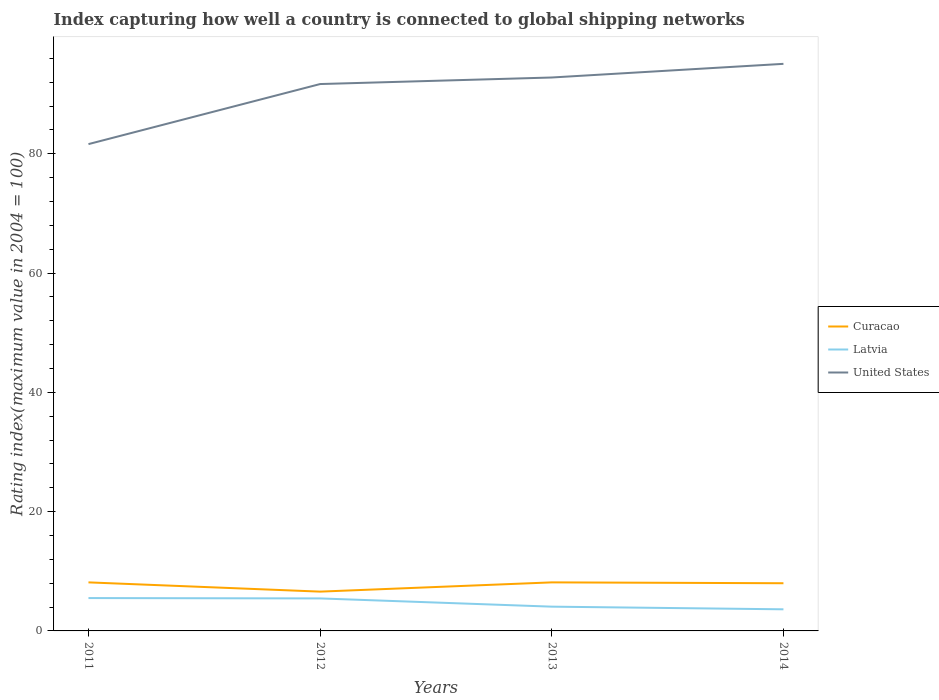How many different coloured lines are there?
Your response must be concise. 3. Does the line corresponding to United States intersect with the line corresponding to Curacao?
Your answer should be very brief. No. Is the number of lines equal to the number of legend labels?
Your response must be concise. Yes. Across all years, what is the maximum rating index in Curacao?
Offer a very short reply. 6.59. In which year was the rating index in United States maximum?
Offer a terse response. 2011. What is the difference between the highest and the second highest rating index in Curacao?
Offer a terse response. 1.55. What is the difference between the highest and the lowest rating index in Latvia?
Keep it short and to the point. 2. Is the rating index in United States strictly greater than the rating index in Latvia over the years?
Make the answer very short. No. How many lines are there?
Give a very brief answer. 3. Does the graph contain grids?
Offer a very short reply. No. How many legend labels are there?
Make the answer very short. 3. How are the legend labels stacked?
Ensure brevity in your answer.  Vertical. What is the title of the graph?
Offer a terse response. Index capturing how well a country is connected to global shipping networks. What is the label or title of the Y-axis?
Give a very brief answer. Rating index(maximum value in 2004 = 100). What is the Rating index(maximum value in 2004 = 100) of Curacao in 2011?
Give a very brief answer. 8.14. What is the Rating index(maximum value in 2004 = 100) of Latvia in 2011?
Your response must be concise. 5.51. What is the Rating index(maximum value in 2004 = 100) in United States in 2011?
Make the answer very short. 81.63. What is the Rating index(maximum value in 2004 = 100) in Curacao in 2012?
Make the answer very short. 6.59. What is the Rating index(maximum value in 2004 = 100) of Latvia in 2012?
Your answer should be very brief. 5.45. What is the Rating index(maximum value in 2004 = 100) of United States in 2012?
Your response must be concise. 91.7. What is the Rating index(maximum value in 2004 = 100) in Curacao in 2013?
Your response must be concise. 8.14. What is the Rating index(maximum value in 2004 = 100) in Latvia in 2013?
Ensure brevity in your answer.  4.07. What is the Rating index(maximum value in 2004 = 100) of United States in 2013?
Provide a succinct answer. 92.8. What is the Rating index(maximum value in 2004 = 100) in Curacao in 2014?
Provide a succinct answer. 8. What is the Rating index(maximum value in 2004 = 100) of Latvia in 2014?
Your answer should be very brief. 3.62. What is the Rating index(maximum value in 2004 = 100) in United States in 2014?
Your response must be concise. 95.09. Across all years, what is the maximum Rating index(maximum value in 2004 = 100) in Curacao?
Provide a succinct answer. 8.14. Across all years, what is the maximum Rating index(maximum value in 2004 = 100) of Latvia?
Your answer should be very brief. 5.51. Across all years, what is the maximum Rating index(maximum value in 2004 = 100) in United States?
Ensure brevity in your answer.  95.09. Across all years, what is the minimum Rating index(maximum value in 2004 = 100) of Curacao?
Give a very brief answer. 6.59. Across all years, what is the minimum Rating index(maximum value in 2004 = 100) of Latvia?
Your answer should be compact. 3.62. Across all years, what is the minimum Rating index(maximum value in 2004 = 100) of United States?
Your response must be concise. 81.63. What is the total Rating index(maximum value in 2004 = 100) of Curacao in the graph?
Offer a very short reply. 30.87. What is the total Rating index(maximum value in 2004 = 100) of Latvia in the graph?
Keep it short and to the point. 18.65. What is the total Rating index(maximum value in 2004 = 100) in United States in the graph?
Provide a short and direct response. 361.22. What is the difference between the Rating index(maximum value in 2004 = 100) in Curacao in 2011 and that in 2012?
Give a very brief answer. 1.55. What is the difference between the Rating index(maximum value in 2004 = 100) of United States in 2011 and that in 2012?
Provide a short and direct response. -10.07. What is the difference between the Rating index(maximum value in 2004 = 100) in Latvia in 2011 and that in 2013?
Keep it short and to the point. 1.44. What is the difference between the Rating index(maximum value in 2004 = 100) of United States in 2011 and that in 2013?
Keep it short and to the point. -11.17. What is the difference between the Rating index(maximum value in 2004 = 100) of Curacao in 2011 and that in 2014?
Offer a terse response. 0.14. What is the difference between the Rating index(maximum value in 2004 = 100) in Latvia in 2011 and that in 2014?
Provide a succinct answer. 1.89. What is the difference between the Rating index(maximum value in 2004 = 100) of United States in 2011 and that in 2014?
Your answer should be compact. -13.46. What is the difference between the Rating index(maximum value in 2004 = 100) of Curacao in 2012 and that in 2013?
Provide a succinct answer. -1.55. What is the difference between the Rating index(maximum value in 2004 = 100) of Latvia in 2012 and that in 2013?
Your answer should be compact. 1.38. What is the difference between the Rating index(maximum value in 2004 = 100) in United States in 2012 and that in 2013?
Offer a terse response. -1.1. What is the difference between the Rating index(maximum value in 2004 = 100) of Curacao in 2012 and that in 2014?
Keep it short and to the point. -1.41. What is the difference between the Rating index(maximum value in 2004 = 100) of Latvia in 2012 and that in 2014?
Offer a very short reply. 1.83. What is the difference between the Rating index(maximum value in 2004 = 100) of United States in 2012 and that in 2014?
Offer a very short reply. -3.39. What is the difference between the Rating index(maximum value in 2004 = 100) in Curacao in 2013 and that in 2014?
Provide a succinct answer. 0.14. What is the difference between the Rating index(maximum value in 2004 = 100) of Latvia in 2013 and that in 2014?
Give a very brief answer. 0.45. What is the difference between the Rating index(maximum value in 2004 = 100) in United States in 2013 and that in 2014?
Give a very brief answer. -2.29. What is the difference between the Rating index(maximum value in 2004 = 100) in Curacao in 2011 and the Rating index(maximum value in 2004 = 100) in Latvia in 2012?
Keep it short and to the point. 2.69. What is the difference between the Rating index(maximum value in 2004 = 100) of Curacao in 2011 and the Rating index(maximum value in 2004 = 100) of United States in 2012?
Ensure brevity in your answer.  -83.56. What is the difference between the Rating index(maximum value in 2004 = 100) in Latvia in 2011 and the Rating index(maximum value in 2004 = 100) in United States in 2012?
Your response must be concise. -86.19. What is the difference between the Rating index(maximum value in 2004 = 100) of Curacao in 2011 and the Rating index(maximum value in 2004 = 100) of Latvia in 2013?
Offer a very short reply. 4.07. What is the difference between the Rating index(maximum value in 2004 = 100) in Curacao in 2011 and the Rating index(maximum value in 2004 = 100) in United States in 2013?
Provide a succinct answer. -84.66. What is the difference between the Rating index(maximum value in 2004 = 100) of Latvia in 2011 and the Rating index(maximum value in 2004 = 100) of United States in 2013?
Give a very brief answer. -87.29. What is the difference between the Rating index(maximum value in 2004 = 100) of Curacao in 2011 and the Rating index(maximum value in 2004 = 100) of Latvia in 2014?
Offer a terse response. 4.52. What is the difference between the Rating index(maximum value in 2004 = 100) in Curacao in 2011 and the Rating index(maximum value in 2004 = 100) in United States in 2014?
Your response must be concise. -86.95. What is the difference between the Rating index(maximum value in 2004 = 100) of Latvia in 2011 and the Rating index(maximum value in 2004 = 100) of United States in 2014?
Make the answer very short. -89.58. What is the difference between the Rating index(maximum value in 2004 = 100) in Curacao in 2012 and the Rating index(maximum value in 2004 = 100) in Latvia in 2013?
Provide a short and direct response. 2.52. What is the difference between the Rating index(maximum value in 2004 = 100) in Curacao in 2012 and the Rating index(maximum value in 2004 = 100) in United States in 2013?
Ensure brevity in your answer.  -86.21. What is the difference between the Rating index(maximum value in 2004 = 100) of Latvia in 2012 and the Rating index(maximum value in 2004 = 100) of United States in 2013?
Offer a terse response. -87.35. What is the difference between the Rating index(maximum value in 2004 = 100) of Curacao in 2012 and the Rating index(maximum value in 2004 = 100) of Latvia in 2014?
Your answer should be compact. 2.97. What is the difference between the Rating index(maximum value in 2004 = 100) of Curacao in 2012 and the Rating index(maximum value in 2004 = 100) of United States in 2014?
Provide a short and direct response. -88.5. What is the difference between the Rating index(maximum value in 2004 = 100) in Latvia in 2012 and the Rating index(maximum value in 2004 = 100) in United States in 2014?
Make the answer very short. -89.64. What is the difference between the Rating index(maximum value in 2004 = 100) of Curacao in 2013 and the Rating index(maximum value in 2004 = 100) of Latvia in 2014?
Offer a terse response. 4.52. What is the difference between the Rating index(maximum value in 2004 = 100) of Curacao in 2013 and the Rating index(maximum value in 2004 = 100) of United States in 2014?
Keep it short and to the point. -86.95. What is the difference between the Rating index(maximum value in 2004 = 100) of Latvia in 2013 and the Rating index(maximum value in 2004 = 100) of United States in 2014?
Make the answer very short. -91.02. What is the average Rating index(maximum value in 2004 = 100) of Curacao per year?
Give a very brief answer. 7.72. What is the average Rating index(maximum value in 2004 = 100) in Latvia per year?
Keep it short and to the point. 4.66. What is the average Rating index(maximum value in 2004 = 100) in United States per year?
Offer a terse response. 90.3. In the year 2011, what is the difference between the Rating index(maximum value in 2004 = 100) in Curacao and Rating index(maximum value in 2004 = 100) in Latvia?
Your response must be concise. 2.63. In the year 2011, what is the difference between the Rating index(maximum value in 2004 = 100) of Curacao and Rating index(maximum value in 2004 = 100) of United States?
Keep it short and to the point. -73.49. In the year 2011, what is the difference between the Rating index(maximum value in 2004 = 100) in Latvia and Rating index(maximum value in 2004 = 100) in United States?
Make the answer very short. -76.12. In the year 2012, what is the difference between the Rating index(maximum value in 2004 = 100) of Curacao and Rating index(maximum value in 2004 = 100) of Latvia?
Give a very brief answer. 1.14. In the year 2012, what is the difference between the Rating index(maximum value in 2004 = 100) of Curacao and Rating index(maximum value in 2004 = 100) of United States?
Keep it short and to the point. -85.11. In the year 2012, what is the difference between the Rating index(maximum value in 2004 = 100) of Latvia and Rating index(maximum value in 2004 = 100) of United States?
Offer a very short reply. -86.25. In the year 2013, what is the difference between the Rating index(maximum value in 2004 = 100) of Curacao and Rating index(maximum value in 2004 = 100) of Latvia?
Offer a very short reply. 4.07. In the year 2013, what is the difference between the Rating index(maximum value in 2004 = 100) of Curacao and Rating index(maximum value in 2004 = 100) of United States?
Provide a succinct answer. -84.66. In the year 2013, what is the difference between the Rating index(maximum value in 2004 = 100) of Latvia and Rating index(maximum value in 2004 = 100) of United States?
Offer a terse response. -88.73. In the year 2014, what is the difference between the Rating index(maximum value in 2004 = 100) in Curacao and Rating index(maximum value in 2004 = 100) in Latvia?
Your answer should be very brief. 4.37. In the year 2014, what is the difference between the Rating index(maximum value in 2004 = 100) of Curacao and Rating index(maximum value in 2004 = 100) of United States?
Offer a terse response. -87.09. In the year 2014, what is the difference between the Rating index(maximum value in 2004 = 100) of Latvia and Rating index(maximum value in 2004 = 100) of United States?
Offer a very short reply. -91.46. What is the ratio of the Rating index(maximum value in 2004 = 100) of Curacao in 2011 to that in 2012?
Provide a short and direct response. 1.24. What is the ratio of the Rating index(maximum value in 2004 = 100) of Latvia in 2011 to that in 2012?
Provide a short and direct response. 1.01. What is the ratio of the Rating index(maximum value in 2004 = 100) in United States in 2011 to that in 2012?
Give a very brief answer. 0.89. What is the ratio of the Rating index(maximum value in 2004 = 100) of Curacao in 2011 to that in 2013?
Provide a succinct answer. 1. What is the ratio of the Rating index(maximum value in 2004 = 100) of Latvia in 2011 to that in 2013?
Ensure brevity in your answer.  1.35. What is the ratio of the Rating index(maximum value in 2004 = 100) of United States in 2011 to that in 2013?
Make the answer very short. 0.88. What is the ratio of the Rating index(maximum value in 2004 = 100) in Curacao in 2011 to that in 2014?
Keep it short and to the point. 1.02. What is the ratio of the Rating index(maximum value in 2004 = 100) of Latvia in 2011 to that in 2014?
Provide a short and direct response. 1.52. What is the ratio of the Rating index(maximum value in 2004 = 100) of United States in 2011 to that in 2014?
Provide a succinct answer. 0.86. What is the ratio of the Rating index(maximum value in 2004 = 100) of Curacao in 2012 to that in 2013?
Ensure brevity in your answer.  0.81. What is the ratio of the Rating index(maximum value in 2004 = 100) in Latvia in 2012 to that in 2013?
Provide a succinct answer. 1.34. What is the ratio of the Rating index(maximum value in 2004 = 100) of Curacao in 2012 to that in 2014?
Make the answer very short. 0.82. What is the ratio of the Rating index(maximum value in 2004 = 100) of Latvia in 2012 to that in 2014?
Give a very brief answer. 1.5. What is the ratio of the Rating index(maximum value in 2004 = 100) in United States in 2012 to that in 2014?
Offer a terse response. 0.96. What is the ratio of the Rating index(maximum value in 2004 = 100) of Curacao in 2013 to that in 2014?
Offer a very short reply. 1.02. What is the ratio of the Rating index(maximum value in 2004 = 100) in Latvia in 2013 to that in 2014?
Your response must be concise. 1.12. What is the ratio of the Rating index(maximum value in 2004 = 100) in United States in 2013 to that in 2014?
Give a very brief answer. 0.98. What is the difference between the highest and the second highest Rating index(maximum value in 2004 = 100) of United States?
Your answer should be very brief. 2.29. What is the difference between the highest and the lowest Rating index(maximum value in 2004 = 100) in Curacao?
Provide a short and direct response. 1.55. What is the difference between the highest and the lowest Rating index(maximum value in 2004 = 100) of Latvia?
Make the answer very short. 1.89. What is the difference between the highest and the lowest Rating index(maximum value in 2004 = 100) in United States?
Keep it short and to the point. 13.46. 